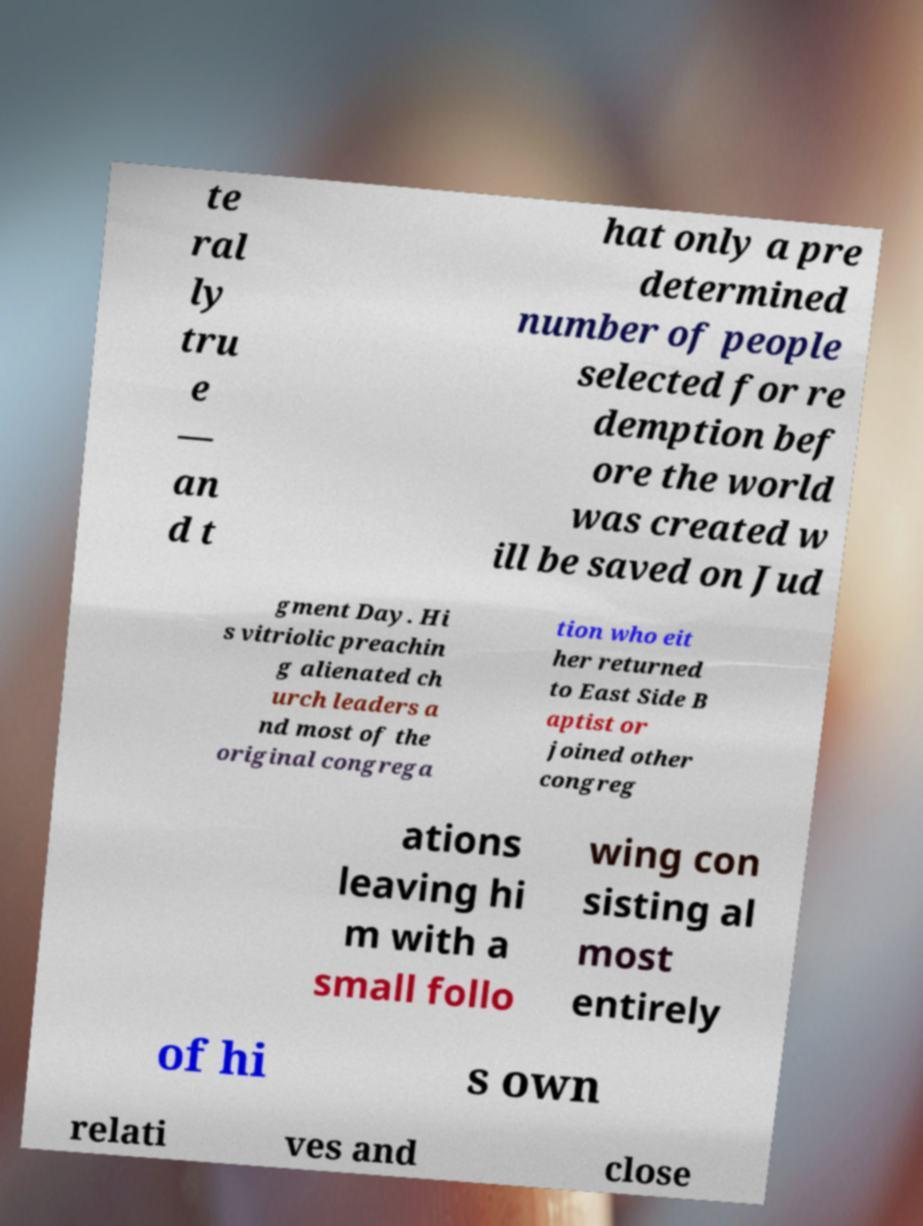There's text embedded in this image that I need extracted. Can you transcribe it verbatim? te ral ly tru e — an d t hat only a pre determined number of people selected for re demption bef ore the world was created w ill be saved on Jud gment Day. Hi s vitriolic preachin g alienated ch urch leaders a nd most of the original congrega tion who eit her returned to East Side B aptist or joined other congreg ations leaving hi m with a small follo wing con sisting al most entirely of hi s own relati ves and close 